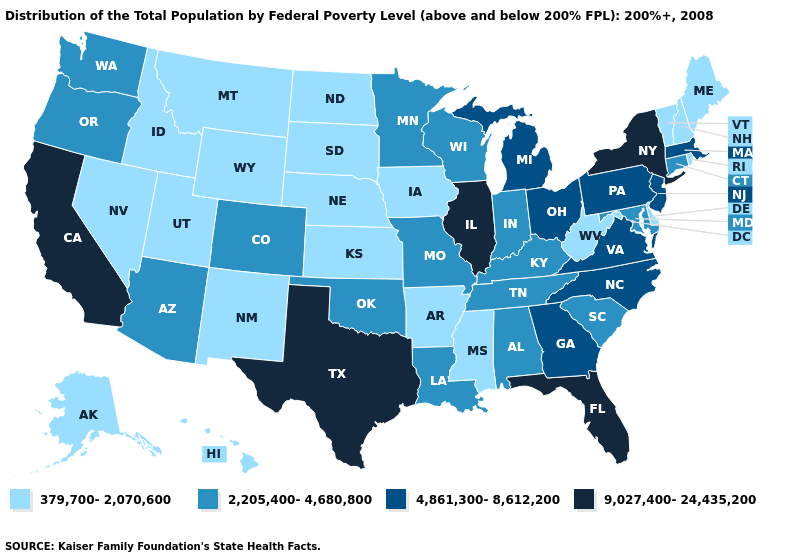Name the states that have a value in the range 9,027,400-24,435,200?
Keep it brief. California, Florida, Illinois, New York, Texas. What is the value of Delaware?
Concise answer only. 379,700-2,070,600. What is the value of Hawaii?
Be succinct. 379,700-2,070,600. What is the value of Colorado?
Quick response, please. 2,205,400-4,680,800. Does Oregon have the lowest value in the West?
Keep it brief. No. What is the lowest value in the West?
Keep it brief. 379,700-2,070,600. Among the states that border Alabama , does Georgia have the highest value?
Keep it brief. No. Name the states that have a value in the range 9,027,400-24,435,200?
Keep it brief. California, Florida, Illinois, New York, Texas. Among the states that border Maine , which have the lowest value?
Quick response, please. New Hampshire. Does Michigan have the same value as Ohio?
Write a very short answer. Yes. What is the value of West Virginia?
Give a very brief answer. 379,700-2,070,600. Among the states that border Idaho , which have the highest value?
Concise answer only. Oregon, Washington. What is the highest value in the USA?
Concise answer only. 9,027,400-24,435,200. Does the map have missing data?
Give a very brief answer. No. What is the value of Colorado?
Keep it brief. 2,205,400-4,680,800. 